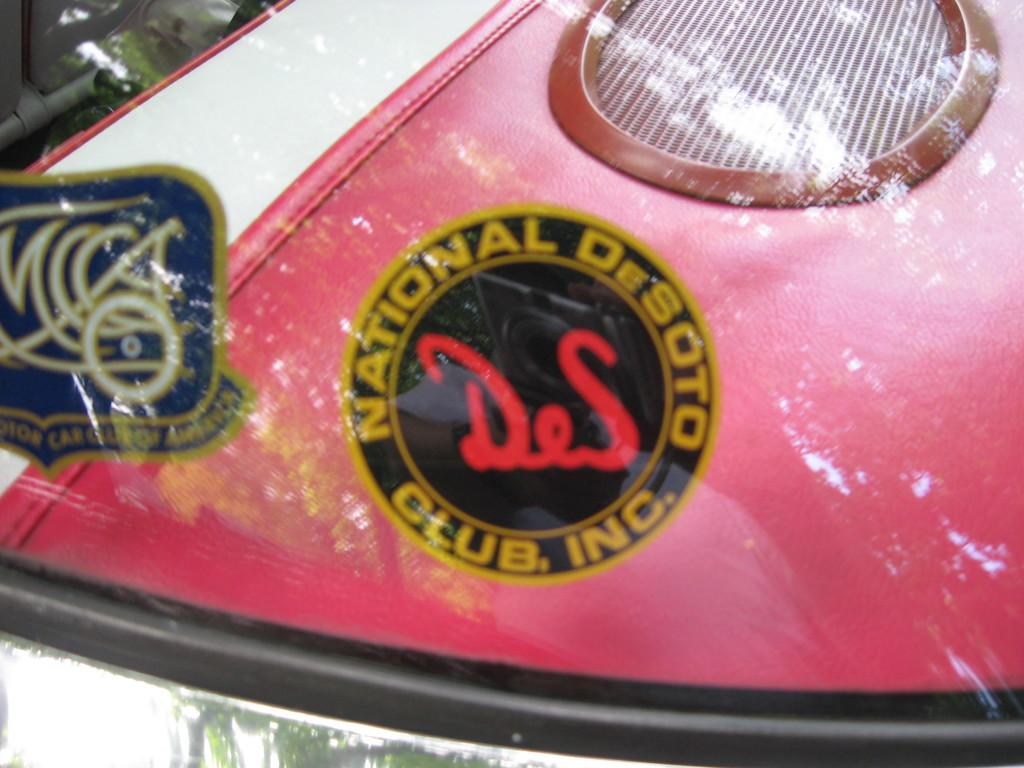What is on the transparent glass in the image? There are stickers on a transparent glass in the image. What can be seen through the transparent glass? A vehicle is visible behind the transparent glass in the image. What type of border can be seen around the stickers on the transparent glass? There is no mention of a border around the stickers in the provided facts, so it cannot be determined from the image. 